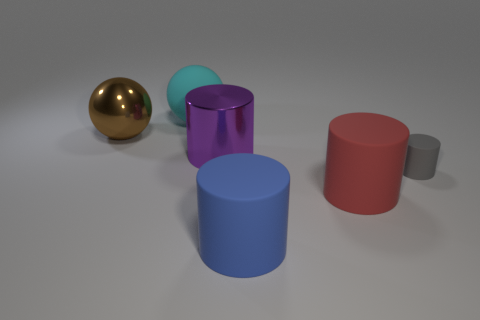Subtract all blue cylinders. How many cylinders are left? 3 Add 1 gray matte things. How many objects exist? 7 Subtract 2 cylinders. How many cylinders are left? 2 Subtract all brown spheres. How many spheres are left? 1 Subtract all spheres. How many objects are left? 4 Subtract all green balls. Subtract all green cylinders. How many balls are left? 2 Subtract all green blocks. How many brown balls are left? 1 Subtract all large cyan matte things. Subtract all large cyan spheres. How many objects are left? 4 Add 4 brown shiny spheres. How many brown shiny spheres are left? 5 Add 3 metallic spheres. How many metallic spheres exist? 4 